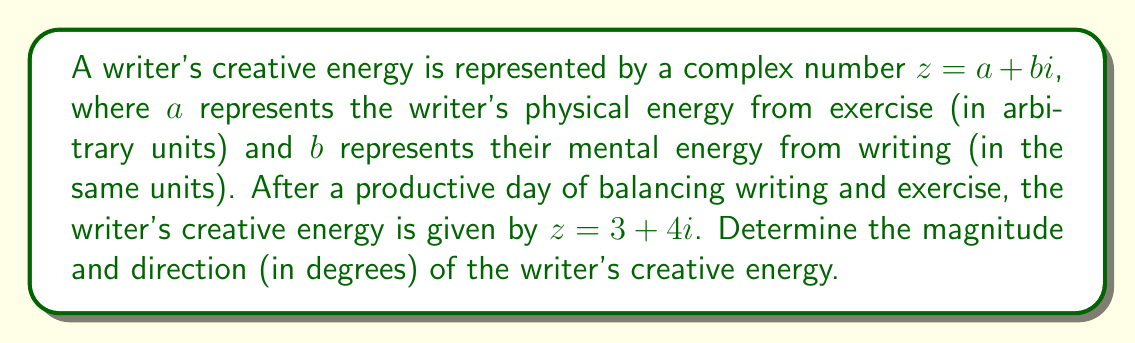Can you solve this math problem? To solve this problem, we need to convert the complex number from rectangular form to polar form. The polar form of a complex number is represented as $r(\cos\theta + i\sin\theta)$ or simply $r\angle\theta$, where $r$ is the magnitude and $\theta$ is the angle (direction).

1. Calculate the magnitude:
   The magnitude $r$ is given by the formula:
   $$r = \sqrt{a^2 + b^2}$$
   Where $a = 3$ and $b = 4$
   $$r = \sqrt{3^2 + 4^2} = \sqrt{9 + 16} = \sqrt{25} = 5$$

2. Calculate the direction:
   The angle $\theta$ is given by the formula:
   $$\theta = \tan^{-1}\left(\frac{b}{a}\right)$$
   $$\theta = \tan^{-1}\left(\frac{4}{3}\right)$$

   To calculate this:
   $$\theta = \tan^{-1}(1.3333...) \approx 0.9272952180 \text{ radians}$$

   Convert radians to degrees:
   $$\theta \text{ (in degrees)} = 0.9272952180 \times \frac{180°}{\pi} \approx 53.13010235°$$

Therefore, the writer's creative energy has a magnitude of 5 units and a direction of approximately 53.13°.
Answer: Magnitude: 5 units
Direction: 53.13° (rounded to two decimal places) 